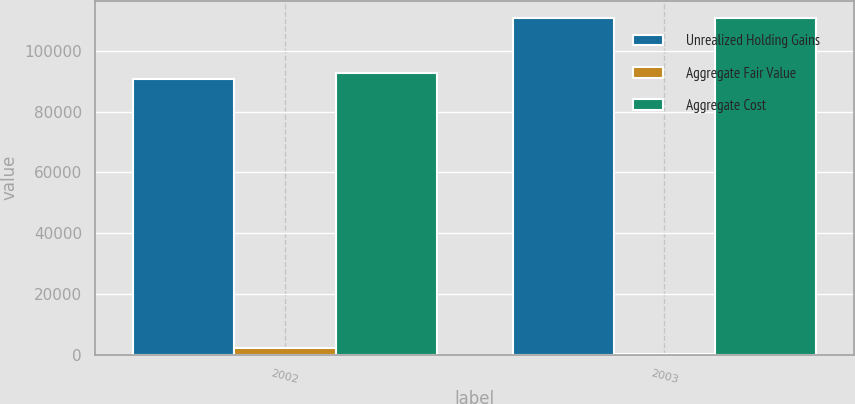Convert chart. <chart><loc_0><loc_0><loc_500><loc_500><stacked_bar_chart><ecel><fcel>2002<fcel>2003<nl><fcel>Unrealized Holding Gains<fcel>90888<fcel>110822<nl><fcel>Aggregate Fair Value<fcel>2020<fcel>140<nl><fcel>Aggregate Cost<fcel>92908<fcel>110962<nl></chart> 